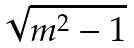<formula> <loc_0><loc_0><loc_500><loc_500>\sqrt { m ^ { 2 } - 1 }</formula> 